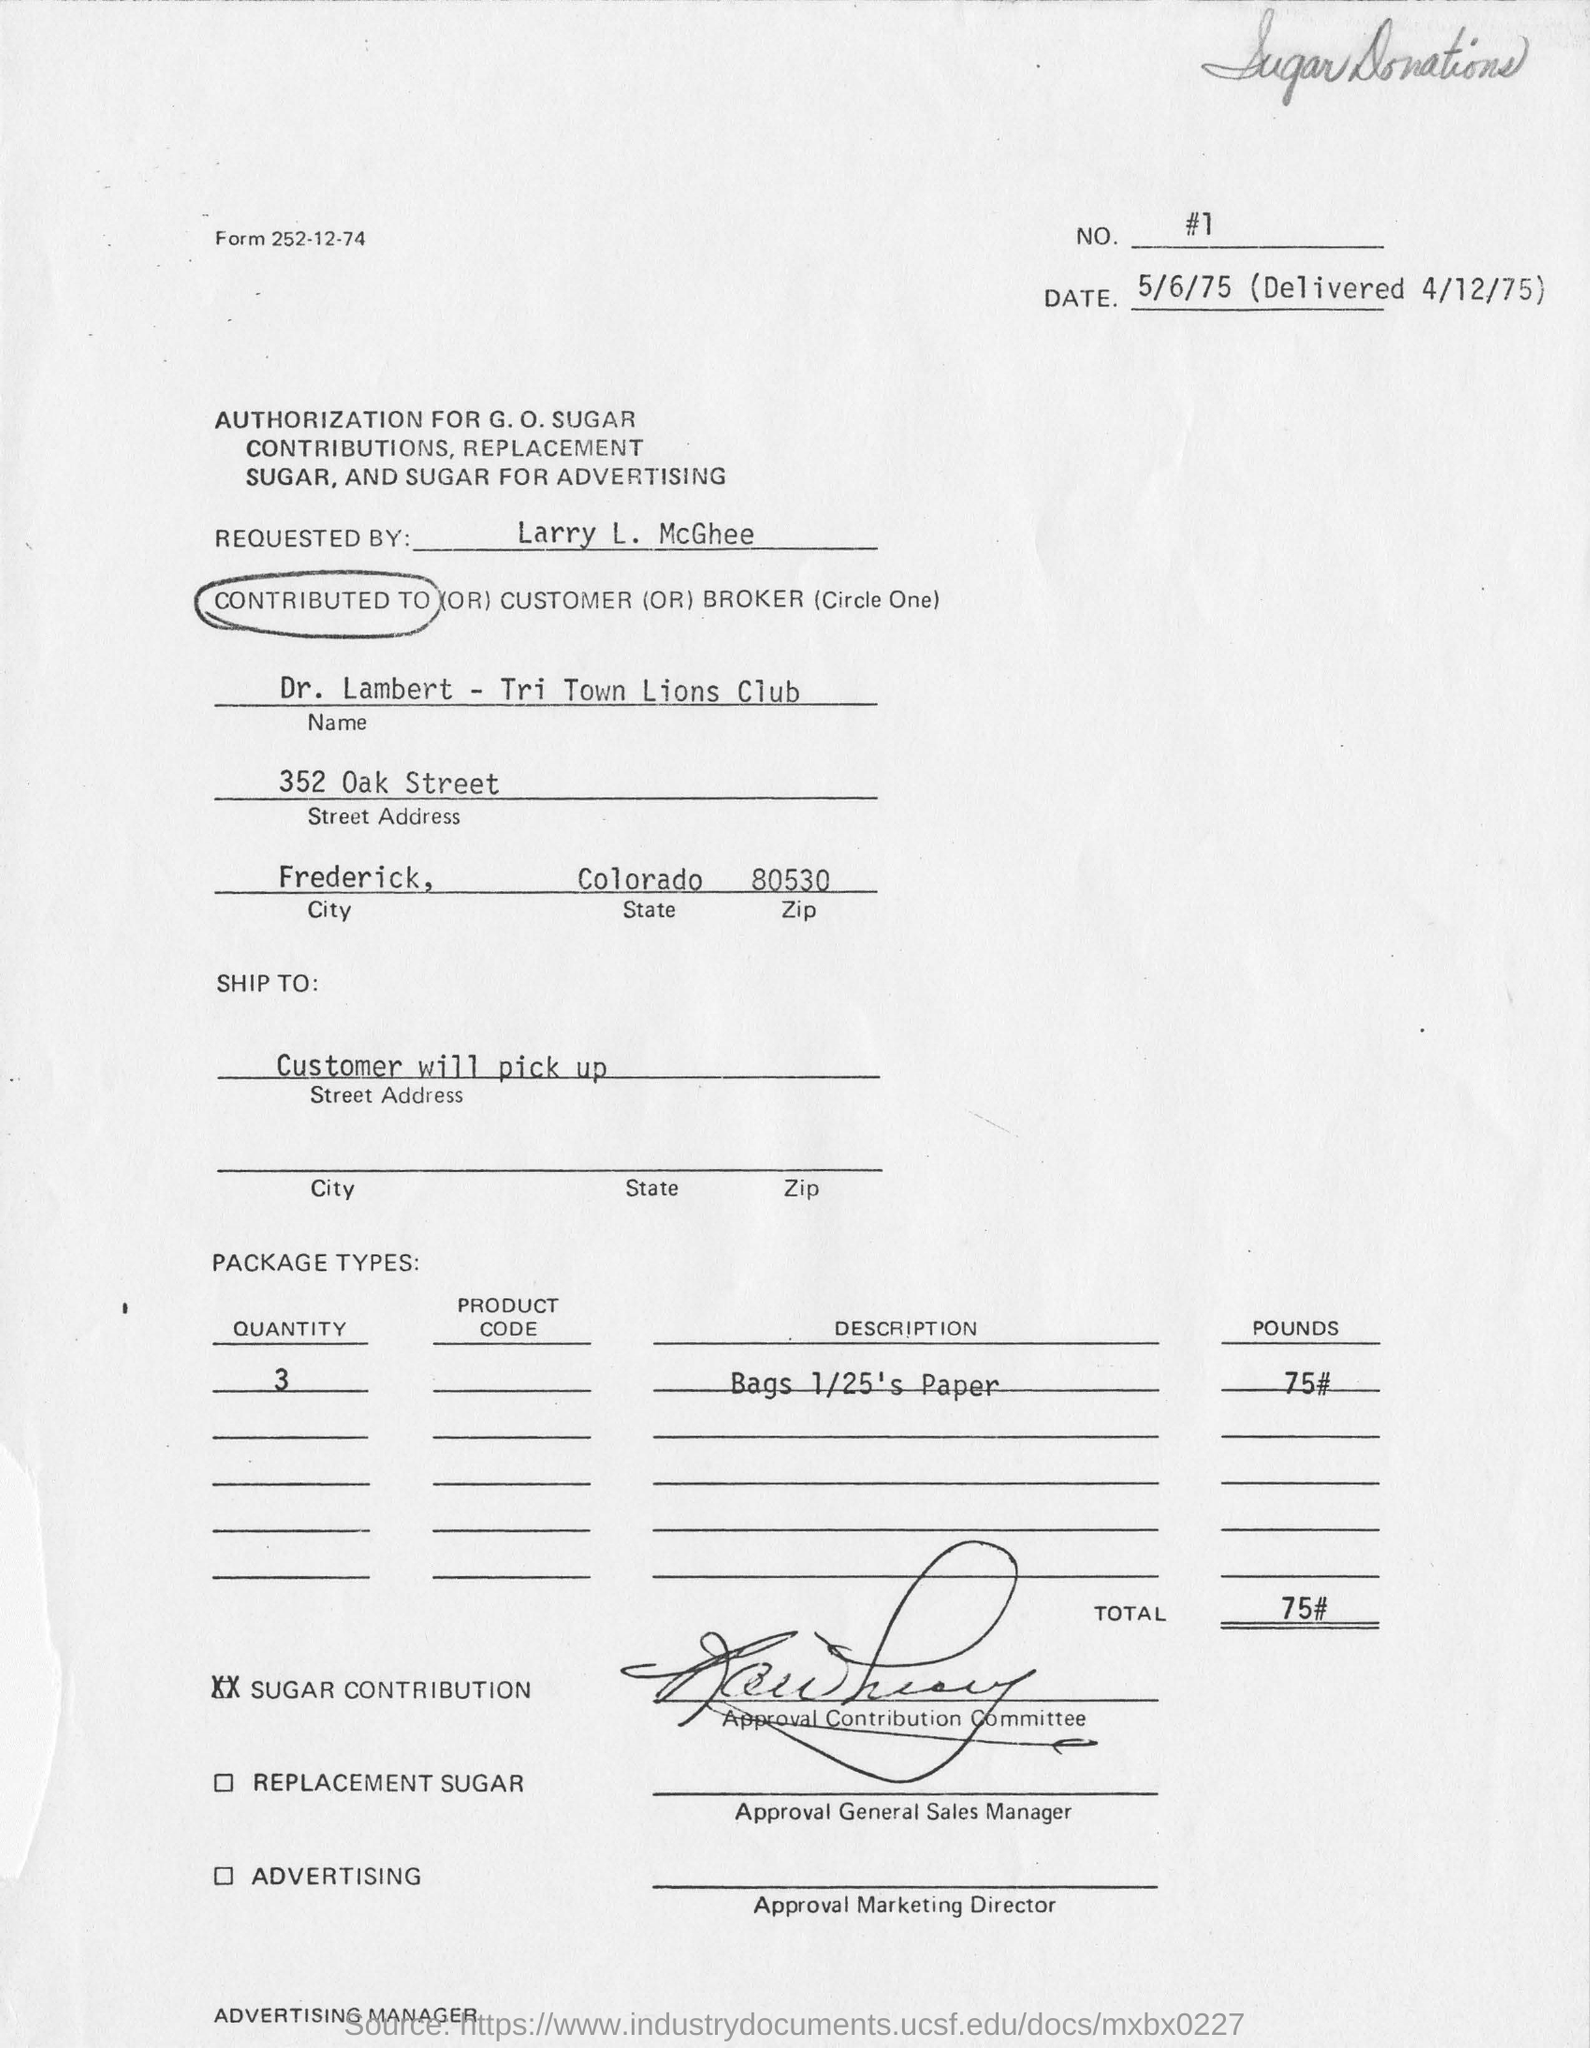Who has requested the authorization for G.O. Sugar contributions?
Your answer should be compact. Larry L. McGhee. Which city is the customer from?
Offer a terse response. Frederick, Colorado. What is the description of the package type?
Offer a very short reply. Bags 1/25's Paper. What is the weight of the package in Pounds?
Your answer should be very brief. 75#. How will the package be received?
Your answer should be compact. Customer will pick up. How many packages will be there?
Give a very brief answer. 3. 